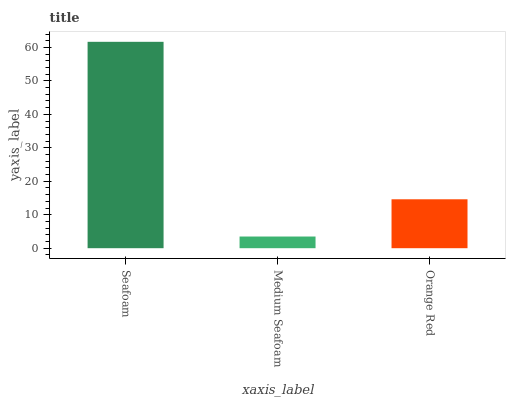Is Orange Red the minimum?
Answer yes or no. No. Is Orange Red the maximum?
Answer yes or no. No. Is Orange Red greater than Medium Seafoam?
Answer yes or no. Yes. Is Medium Seafoam less than Orange Red?
Answer yes or no. Yes. Is Medium Seafoam greater than Orange Red?
Answer yes or no. No. Is Orange Red less than Medium Seafoam?
Answer yes or no. No. Is Orange Red the high median?
Answer yes or no. Yes. Is Orange Red the low median?
Answer yes or no. Yes. Is Seafoam the high median?
Answer yes or no. No. Is Seafoam the low median?
Answer yes or no. No. 